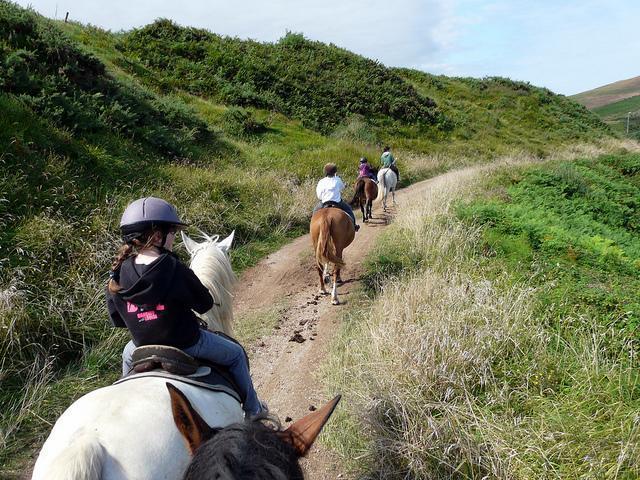How many people are there?
Give a very brief answer. 4. How many horses are visible?
Give a very brief answer. 3. How many remotes are there?
Give a very brief answer. 0. 